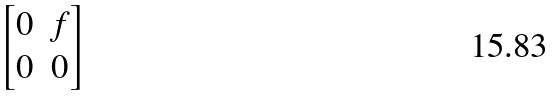<formula> <loc_0><loc_0><loc_500><loc_500>\begin{bmatrix} 0 & f \\ 0 & 0 \end{bmatrix}</formula> 